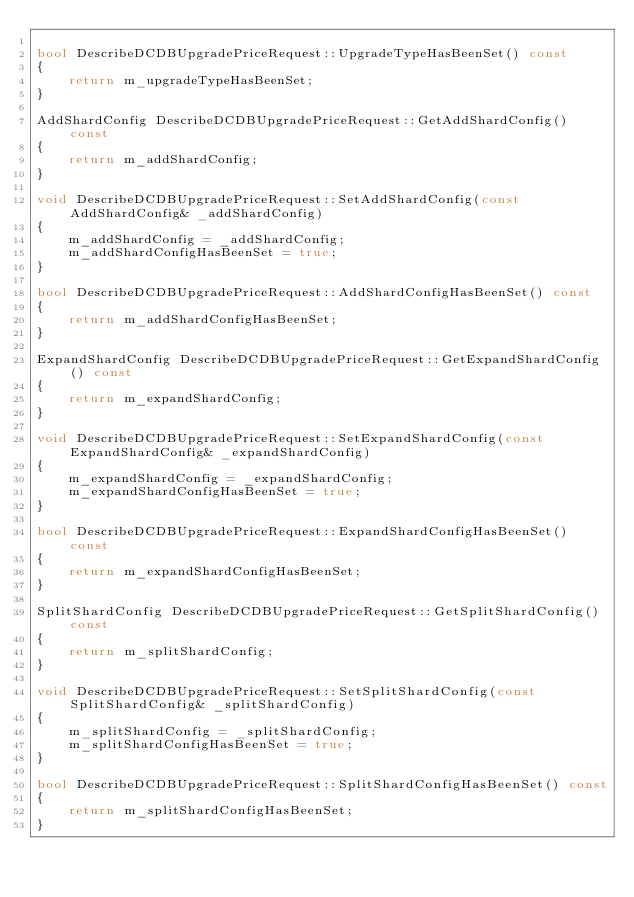Convert code to text. <code><loc_0><loc_0><loc_500><loc_500><_C++_>
bool DescribeDCDBUpgradePriceRequest::UpgradeTypeHasBeenSet() const
{
    return m_upgradeTypeHasBeenSet;
}

AddShardConfig DescribeDCDBUpgradePriceRequest::GetAddShardConfig() const
{
    return m_addShardConfig;
}

void DescribeDCDBUpgradePriceRequest::SetAddShardConfig(const AddShardConfig& _addShardConfig)
{
    m_addShardConfig = _addShardConfig;
    m_addShardConfigHasBeenSet = true;
}

bool DescribeDCDBUpgradePriceRequest::AddShardConfigHasBeenSet() const
{
    return m_addShardConfigHasBeenSet;
}

ExpandShardConfig DescribeDCDBUpgradePriceRequest::GetExpandShardConfig() const
{
    return m_expandShardConfig;
}

void DescribeDCDBUpgradePriceRequest::SetExpandShardConfig(const ExpandShardConfig& _expandShardConfig)
{
    m_expandShardConfig = _expandShardConfig;
    m_expandShardConfigHasBeenSet = true;
}

bool DescribeDCDBUpgradePriceRequest::ExpandShardConfigHasBeenSet() const
{
    return m_expandShardConfigHasBeenSet;
}

SplitShardConfig DescribeDCDBUpgradePriceRequest::GetSplitShardConfig() const
{
    return m_splitShardConfig;
}

void DescribeDCDBUpgradePriceRequest::SetSplitShardConfig(const SplitShardConfig& _splitShardConfig)
{
    m_splitShardConfig = _splitShardConfig;
    m_splitShardConfigHasBeenSet = true;
}

bool DescribeDCDBUpgradePriceRequest::SplitShardConfigHasBeenSet() const
{
    return m_splitShardConfigHasBeenSet;
}


</code> 